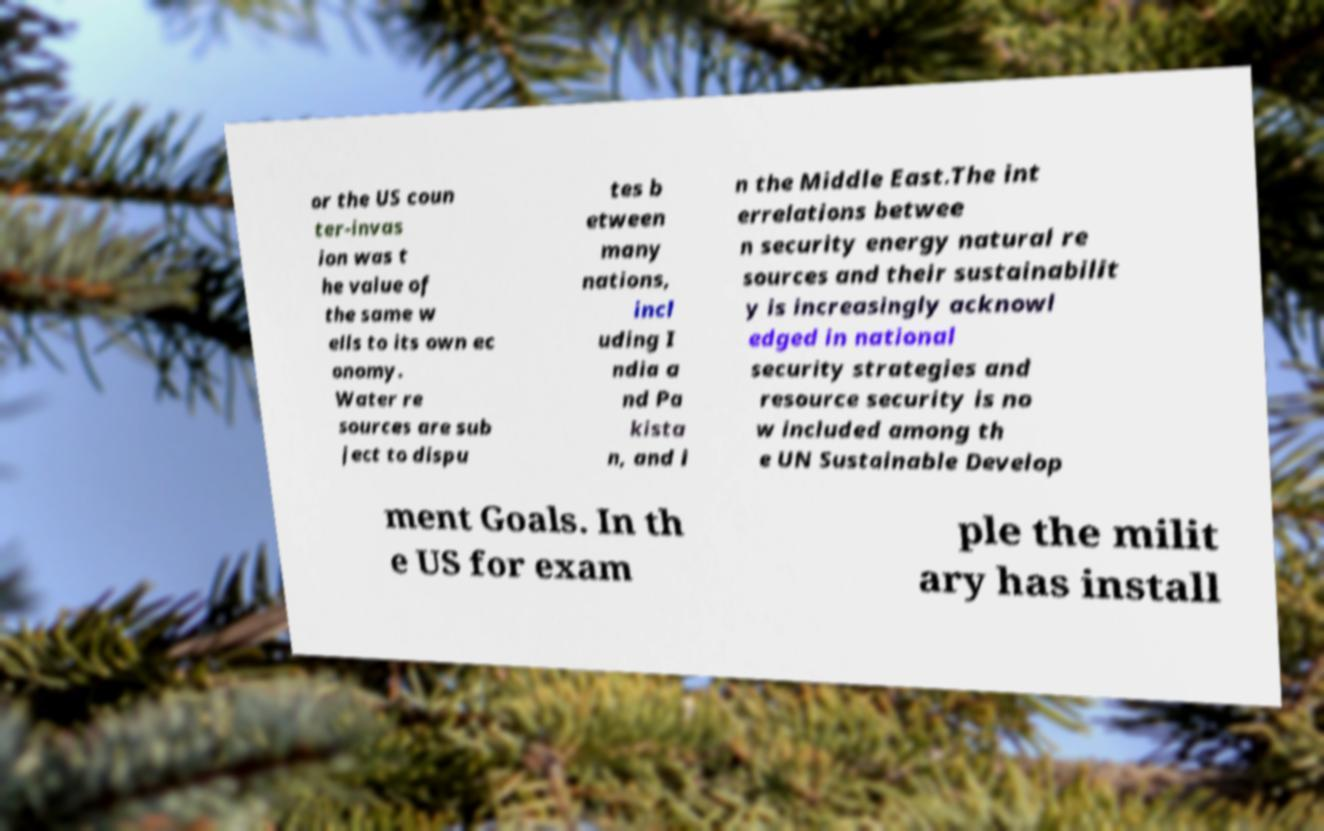Could you extract and type out the text from this image? or the US coun ter-invas ion was t he value of the same w ells to its own ec onomy. Water re sources are sub ject to dispu tes b etween many nations, incl uding I ndia a nd Pa kista n, and i n the Middle East.The int errelations betwee n security energy natural re sources and their sustainabilit y is increasingly acknowl edged in national security strategies and resource security is no w included among th e UN Sustainable Develop ment Goals. In th e US for exam ple the milit ary has install 